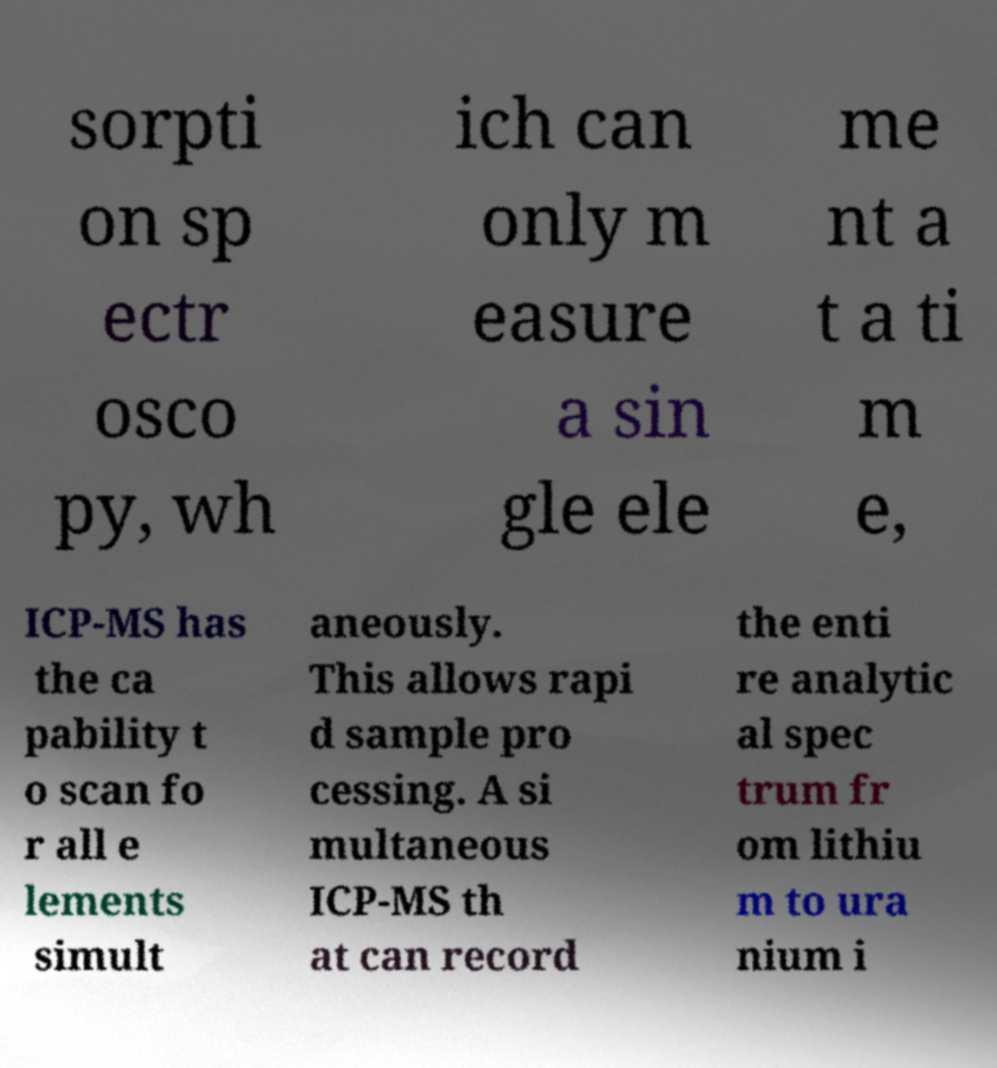Please read and relay the text visible in this image. What does it say? sorpti on sp ectr osco py, wh ich can only m easure a sin gle ele me nt a t a ti m e, ICP-MS has the ca pability t o scan fo r all e lements simult aneously. This allows rapi d sample pro cessing. A si multaneous ICP-MS th at can record the enti re analytic al spec trum fr om lithiu m to ura nium i 